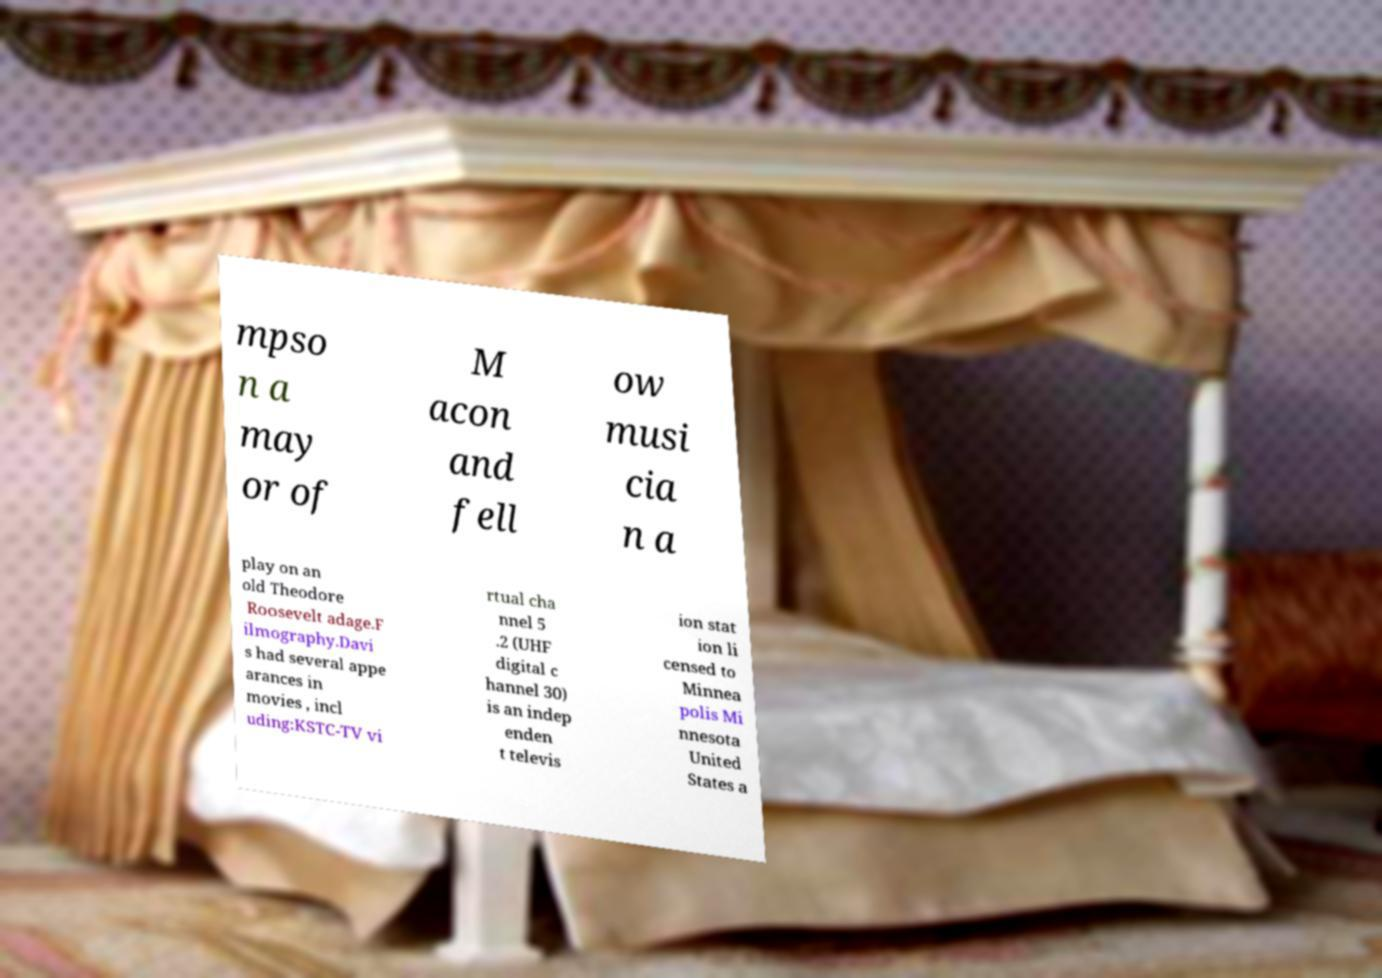What messages or text are displayed in this image? I need them in a readable, typed format. mpso n a may or of M acon and fell ow musi cia n a play on an old Theodore Roosevelt adage.F ilmography.Davi s had several appe arances in movies , incl uding:KSTC-TV vi rtual cha nnel 5 .2 (UHF digital c hannel 30) is an indep enden t televis ion stat ion li censed to Minnea polis Mi nnesota United States a 